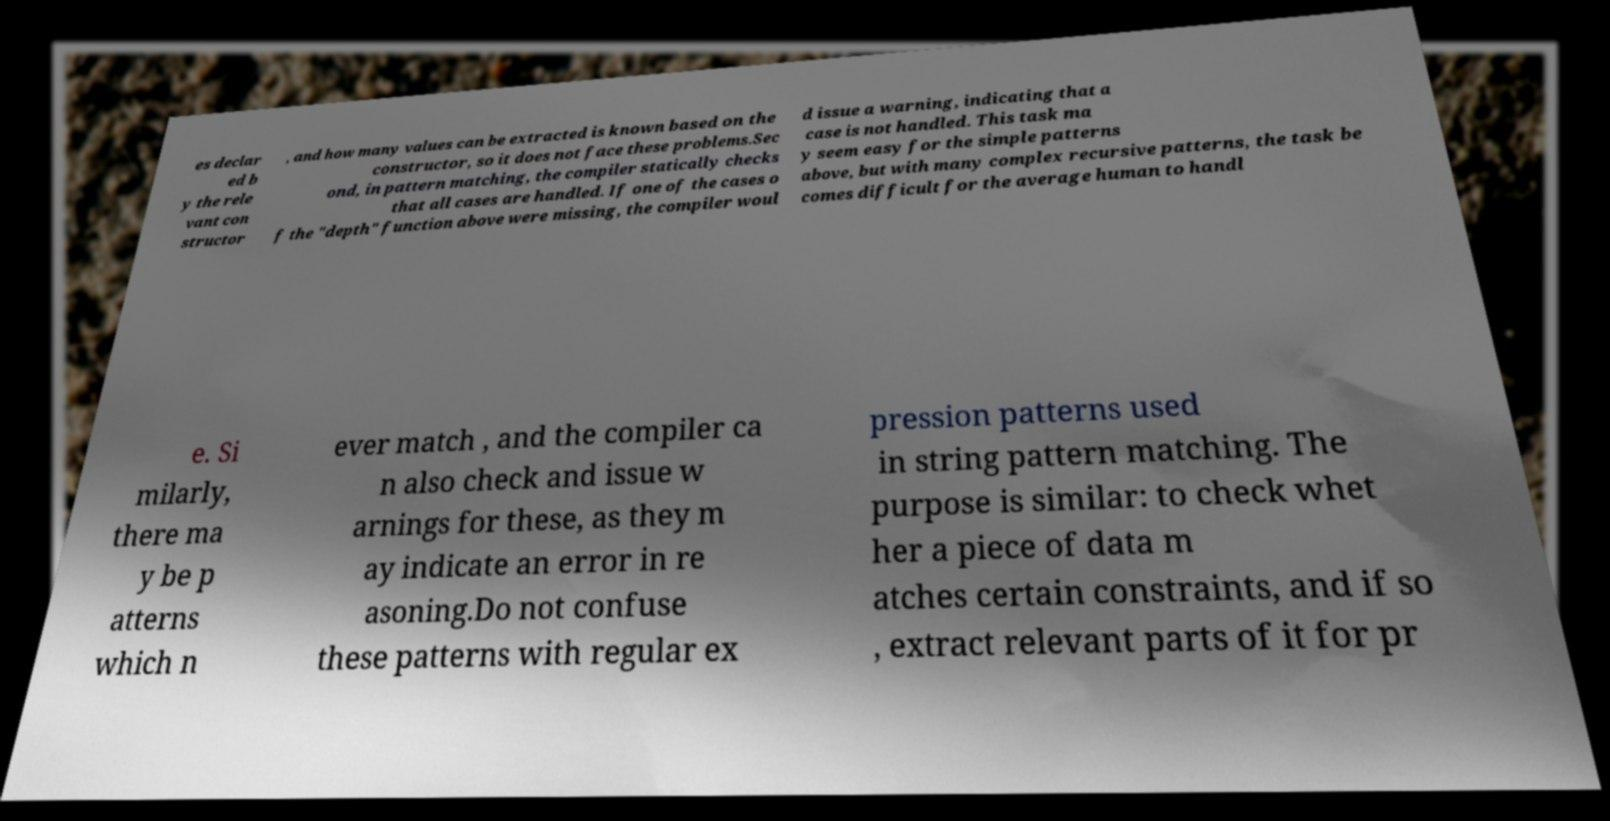There's text embedded in this image that I need extracted. Can you transcribe it verbatim? es declar ed b y the rele vant con structor , and how many values can be extracted is known based on the constructor, so it does not face these problems.Sec ond, in pattern matching, the compiler statically checks that all cases are handled. If one of the cases o f the "depth" function above were missing, the compiler woul d issue a warning, indicating that a case is not handled. This task ma y seem easy for the simple patterns above, but with many complex recursive patterns, the task be comes difficult for the average human to handl e. Si milarly, there ma y be p atterns which n ever match , and the compiler ca n also check and issue w arnings for these, as they m ay indicate an error in re asoning.Do not confuse these patterns with regular ex pression patterns used in string pattern matching. The purpose is similar: to check whet her a piece of data m atches certain constraints, and if so , extract relevant parts of it for pr 